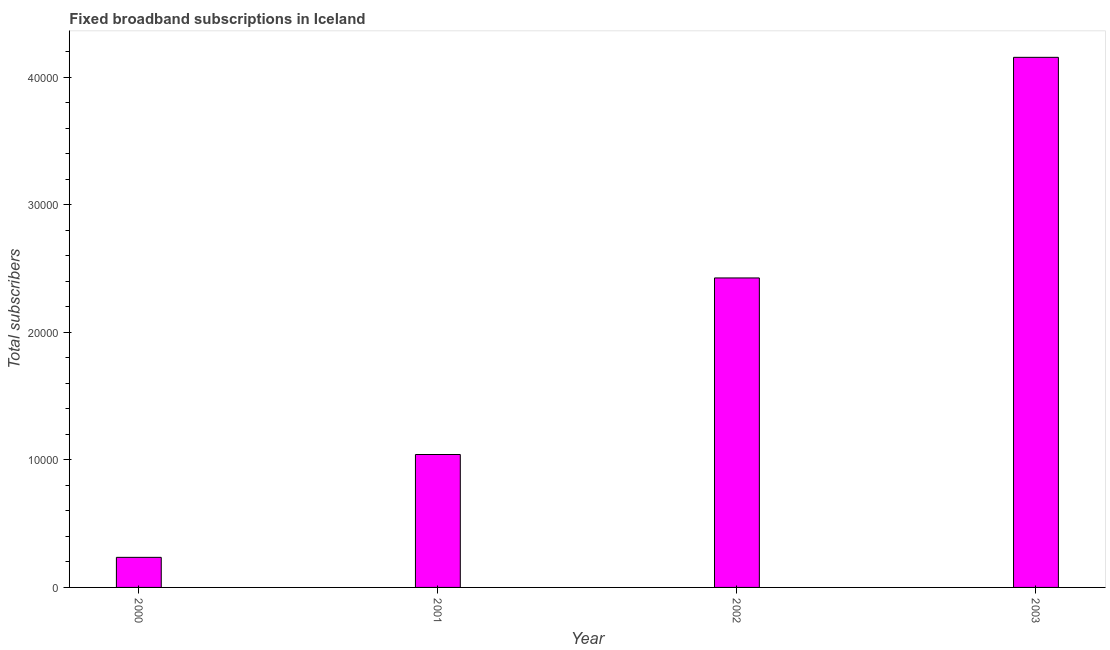Does the graph contain any zero values?
Your response must be concise. No. Does the graph contain grids?
Your answer should be very brief. No. What is the title of the graph?
Make the answer very short. Fixed broadband subscriptions in Iceland. What is the label or title of the Y-axis?
Keep it short and to the point. Total subscribers. What is the total number of fixed broadband subscriptions in 2002?
Provide a succinct answer. 2.43e+04. Across all years, what is the maximum total number of fixed broadband subscriptions?
Provide a short and direct response. 4.16e+04. Across all years, what is the minimum total number of fixed broadband subscriptions?
Your response must be concise. 2358. In which year was the total number of fixed broadband subscriptions maximum?
Your answer should be compact. 2003. What is the sum of the total number of fixed broadband subscriptions?
Make the answer very short. 7.86e+04. What is the difference between the total number of fixed broadband subscriptions in 2001 and 2003?
Keep it short and to the point. -3.11e+04. What is the average total number of fixed broadband subscriptions per year?
Keep it short and to the point. 1.97e+04. What is the median total number of fixed broadband subscriptions?
Ensure brevity in your answer.  1.73e+04. In how many years, is the total number of fixed broadband subscriptions greater than 6000 ?
Offer a very short reply. 3. Do a majority of the years between 2002 and 2003 (inclusive) have total number of fixed broadband subscriptions greater than 36000 ?
Make the answer very short. No. What is the ratio of the total number of fixed broadband subscriptions in 2000 to that in 2001?
Provide a short and direct response. 0.23. Is the difference between the total number of fixed broadband subscriptions in 2000 and 2002 greater than the difference between any two years?
Offer a very short reply. No. What is the difference between the highest and the second highest total number of fixed broadband subscriptions?
Offer a very short reply. 1.73e+04. Is the sum of the total number of fixed broadband subscriptions in 2000 and 2001 greater than the maximum total number of fixed broadband subscriptions across all years?
Ensure brevity in your answer.  No. What is the difference between the highest and the lowest total number of fixed broadband subscriptions?
Provide a succinct answer. 3.92e+04. In how many years, is the total number of fixed broadband subscriptions greater than the average total number of fixed broadband subscriptions taken over all years?
Offer a very short reply. 2. How many bars are there?
Provide a succinct answer. 4. Are all the bars in the graph horizontal?
Ensure brevity in your answer.  No. How many years are there in the graph?
Offer a very short reply. 4. Are the values on the major ticks of Y-axis written in scientific E-notation?
Offer a terse response. No. What is the Total subscribers of 2000?
Your response must be concise. 2358. What is the Total subscribers of 2001?
Offer a terse response. 1.04e+04. What is the Total subscribers of 2002?
Offer a terse response. 2.43e+04. What is the Total subscribers in 2003?
Your answer should be compact. 4.16e+04. What is the difference between the Total subscribers in 2000 and 2001?
Your response must be concise. -8066. What is the difference between the Total subscribers in 2000 and 2002?
Offer a terse response. -2.19e+04. What is the difference between the Total subscribers in 2000 and 2003?
Give a very brief answer. -3.92e+04. What is the difference between the Total subscribers in 2001 and 2002?
Provide a short and direct response. -1.38e+04. What is the difference between the Total subscribers in 2001 and 2003?
Your answer should be very brief. -3.11e+04. What is the difference between the Total subscribers in 2002 and 2003?
Your response must be concise. -1.73e+04. What is the ratio of the Total subscribers in 2000 to that in 2001?
Your answer should be compact. 0.23. What is the ratio of the Total subscribers in 2000 to that in 2002?
Provide a succinct answer. 0.1. What is the ratio of the Total subscribers in 2000 to that in 2003?
Provide a succinct answer. 0.06. What is the ratio of the Total subscribers in 2001 to that in 2002?
Give a very brief answer. 0.43. What is the ratio of the Total subscribers in 2001 to that in 2003?
Provide a short and direct response. 0.25. What is the ratio of the Total subscribers in 2002 to that in 2003?
Make the answer very short. 0.58. 